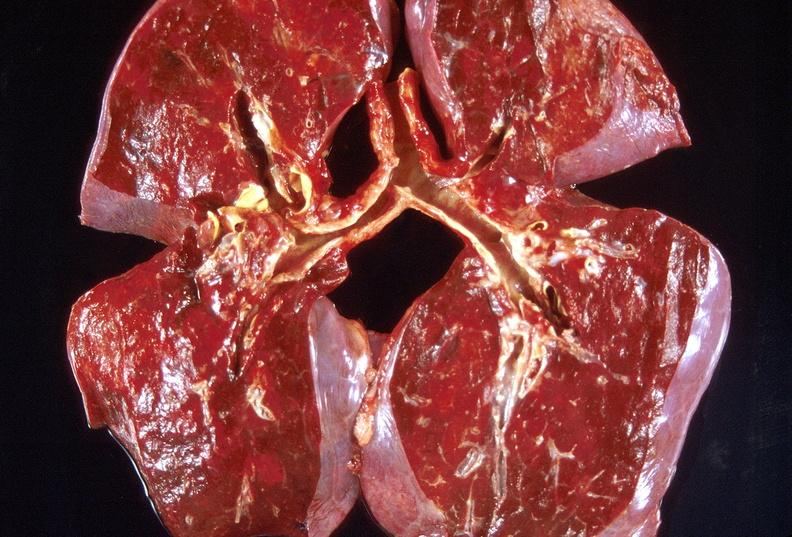s meningitis acute present?
Answer the question using a single word or phrase. No 